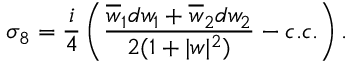<formula> <loc_0><loc_0><loc_500><loc_500>\sigma _ { 8 } = { \frac { i } { 4 } } \left ( { \frac { \overline { w } _ { 1 } d w _ { 1 } + \overline { w } _ { 2 } d w _ { 2 } } { 2 ( 1 + | w | ^ { 2 } ) } } - c . c . \right ) .</formula> 